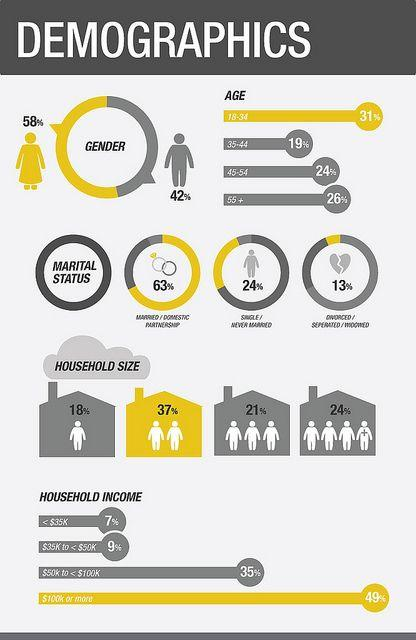Give some essential details in this illustration. The household size is 2, and if we express the percentage of income spent on housing as a percentage of household income, it is 37%. Out of every 100 household members, 18% have experienced hunger. According to the data, 24% of respondents who reported their marital status as "Single. Out of the individuals surveyed with marital status 'Married', 63% were found to have a certain characteristic. 